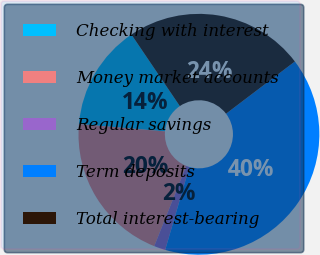Convert chart. <chart><loc_0><loc_0><loc_500><loc_500><pie_chart><fcel>Checking with interest<fcel>Money market accounts<fcel>Regular savings<fcel>Term deposits<fcel>Total interest-bearing<nl><fcel>14.18%<fcel>20.31%<fcel>1.53%<fcel>39.85%<fcel>24.14%<nl></chart> 